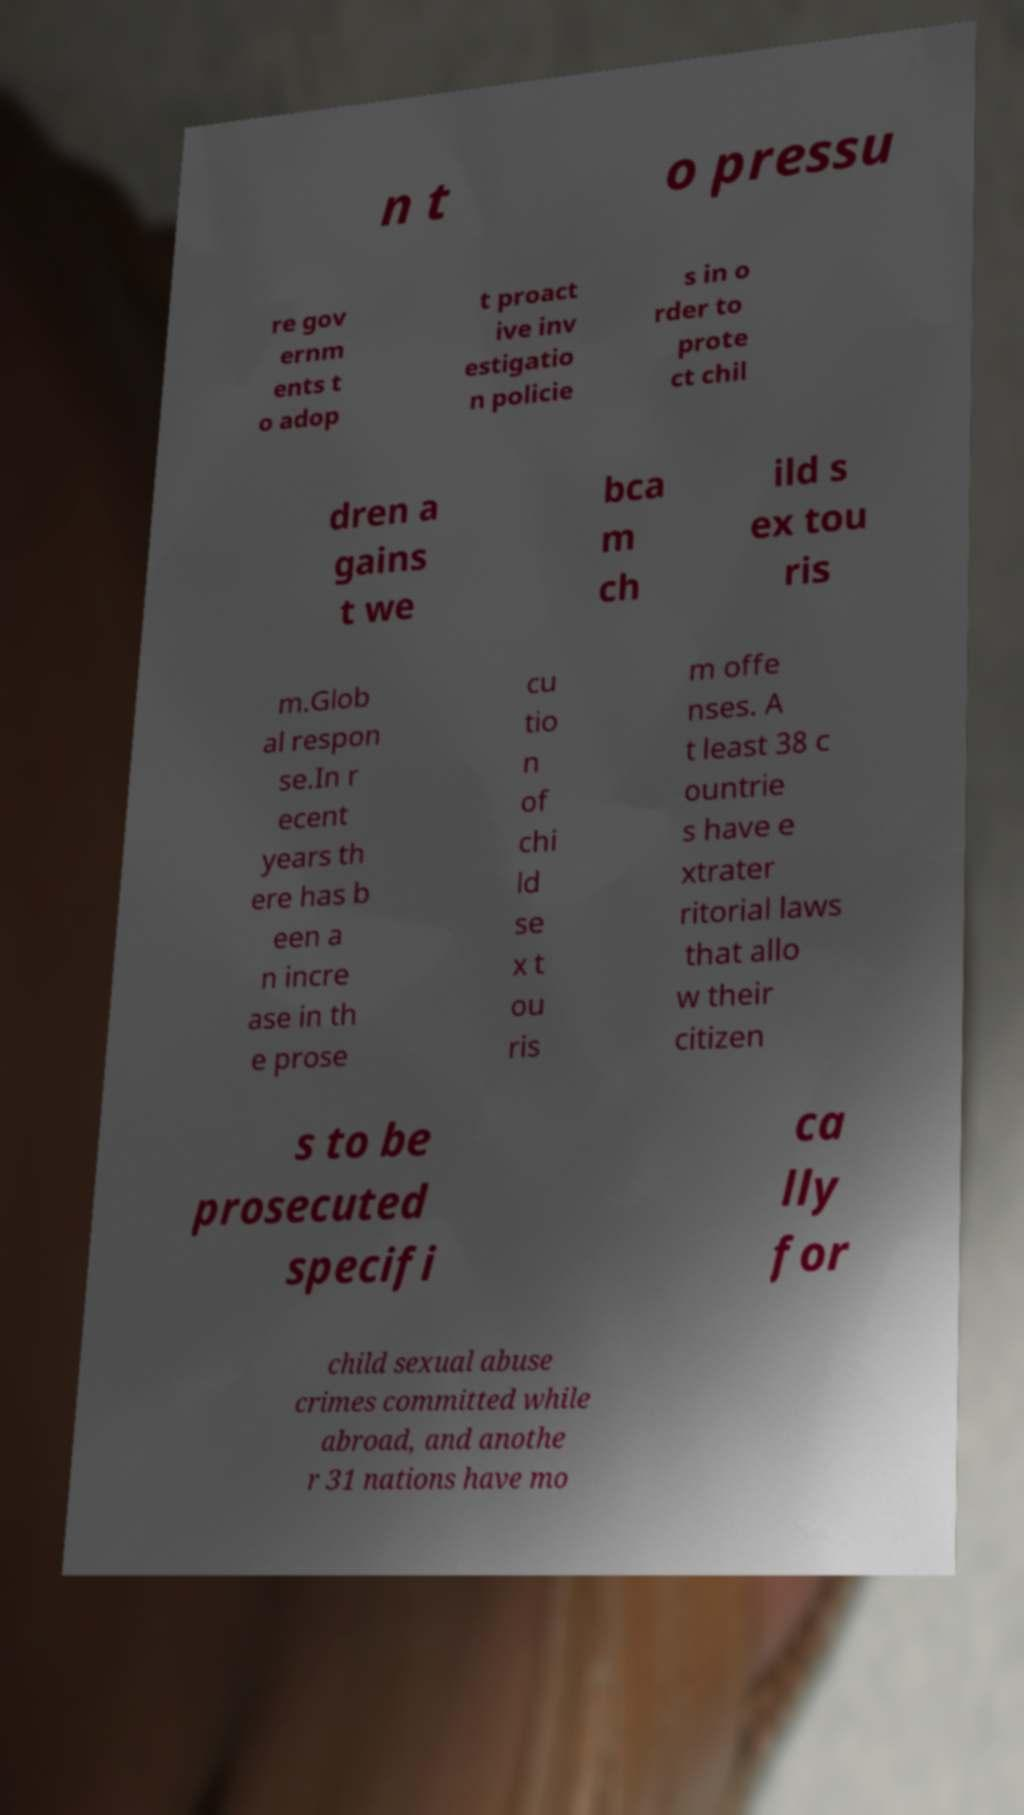What messages or text are displayed in this image? I need them in a readable, typed format. n t o pressu re gov ernm ents t o adop t proact ive inv estigatio n policie s in o rder to prote ct chil dren a gains t we bca m ch ild s ex tou ris m.Glob al respon se.In r ecent years th ere has b een a n incre ase in th e prose cu tio n of chi ld se x t ou ris m offe nses. A t least 38 c ountrie s have e xtrater ritorial laws that allo w their citizen s to be prosecuted specifi ca lly for child sexual abuse crimes committed while abroad, and anothe r 31 nations have mo 